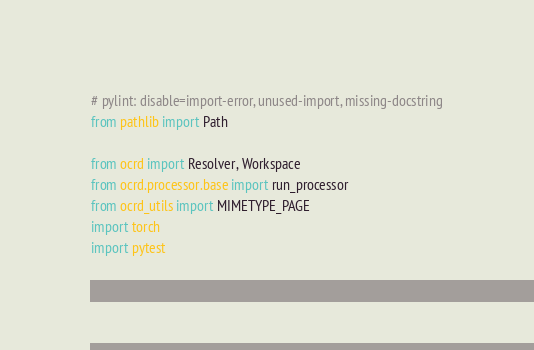Convert code to text. <code><loc_0><loc_0><loc_500><loc_500><_Python_># pylint: disable=import-error, unused-import, missing-docstring
from pathlib import Path

from ocrd import Resolver, Workspace
from ocrd.processor.base import run_processor
from ocrd_utils import MIMETYPE_PAGE
import torch
import pytest
</code> 